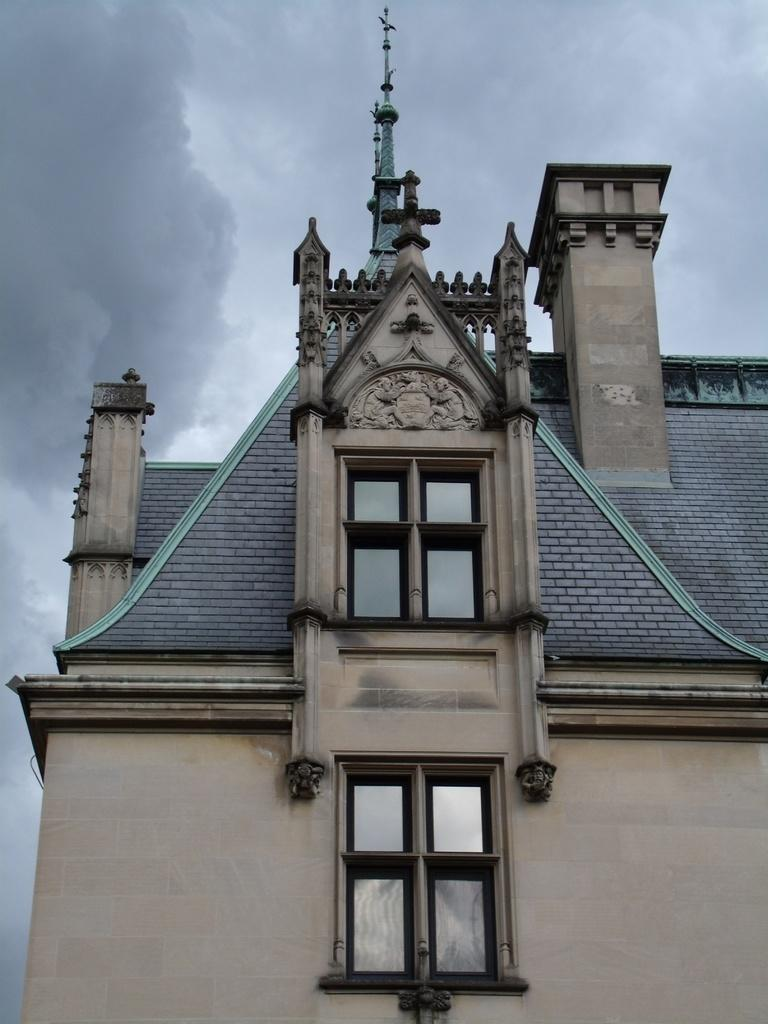What can be seen on the wall in the image? There are statues on the wall in the image. What architectural feature allows light to enter the building in the image? There are windows in the image. What is visible at the top of the building in the image? Poles are visible at the top of the building in the image. What is visible in the background of the image? The sky is visible in the background of the image. What can be observed in the sky in the image? Clouds are present in the sky. What type of whistle can be heard coming from the statue in the image? There is no whistle present in the image, and the statues are not depicted as making any sounds. What type of skin is visible on the statues in the image? The statues in the image are not made of skin; they are likely made of stone or another material. 